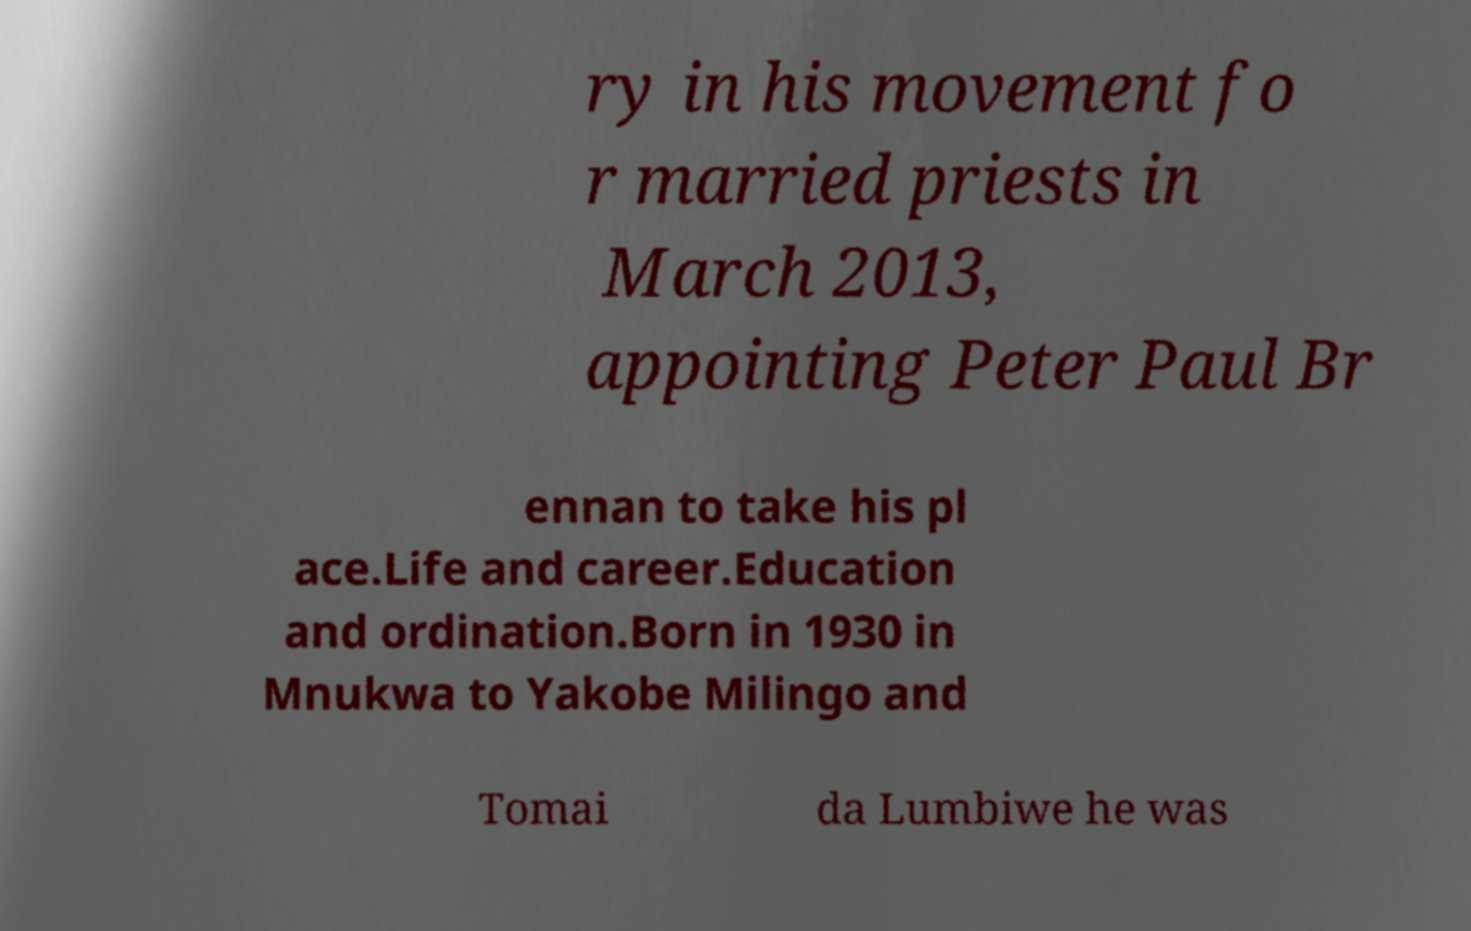Can you accurately transcribe the text from the provided image for me? ry in his movement fo r married priests in March 2013, appointing Peter Paul Br ennan to take his pl ace.Life and career.Education and ordination.Born in 1930 in Mnukwa to Yakobe Milingo and Tomai da Lumbiwe he was 